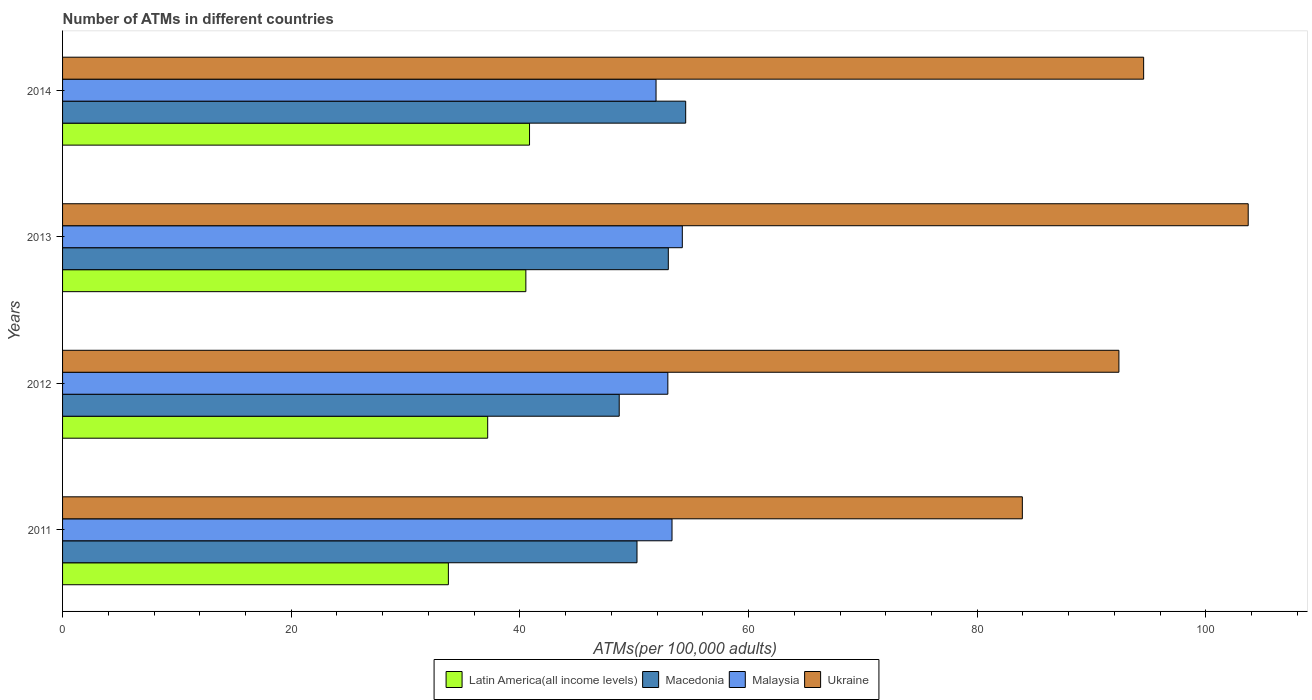How many different coloured bars are there?
Offer a very short reply. 4. How many bars are there on the 4th tick from the top?
Provide a succinct answer. 4. What is the label of the 2nd group of bars from the top?
Ensure brevity in your answer.  2013. What is the number of ATMs in Ukraine in 2011?
Provide a succinct answer. 83.95. Across all years, what is the maximum number of ATMs in Latin America(all income levels)?
Keep it short and to the point. 40.84. Across all years, what is the minimum number of ATMs in Malaysia?
Ensure brevity in your answer.  51.91. What is the total number of ATMs in Malaysia in the graph?
Give a very brief answer. 212.36. What is the difference between the number of ATMs in Macedonia in 2011 and that in 2012?
Offer a very short reply. 1.56. What is the difference between the number of ATMs in Macedonia in 2011 and the number of ATMs in Malaysia in 2012?
Provide a short and direct response. -2.7. What is the average number of ATMs in Macedonia per year?
Your answer should be compact. 51.6. In the year 2013, what is the difference between the number of ATMs in Ukraine and number of ATMs in Macedonia?
Give a very brief answer. 50.72. In how many years, is the number of ATMs in Ukraine greater than 80 ?
Keep it short and to the point. 4. What is the ratio of the number of ATMs in Latin America(all income levels) in 2011 to that in 2012?
Your answer should be compact. 0.91. Is the number of ATMs in Malaysia in 2011 less than that in 2013?
Your answer should be very brief. Yes. Is the difference between the number of ATMs in Ukraine in 2011 and 2012 greater than the difference between the number of ATMs in Macedonia in 2011 and 2012?
Your answer should be compact. No. What is the difference between the highest and the second highest number of ATMs in Ukraine?
Give a very brief answer. 9.15. What is the difference between the highest and the lowest number of ATMs in Macedonia?
Keep it short and to the point. 5.81. Is it the case that in every year, the sum of the number of ATMs in Latin America(all income levels) and number of ATMs in Macedonia is greater than the sum of number of ATMs in Ukraine and number of ATMs in Malaysia?
Your response must be concise. No. What does the 3rd bar from the top in 2012 represents?
Keep it short and to the point. Macedonia. What does the 2nd bar from the bottom in 2013 represents?
Your answer should be compact. Macedonia. Is it the case that in every year, the sum of the number of ATMs in Ukraine and number of ATMs in Macedonia is greater than the number of ATMs in Latin America(all income levels)?
Make the answer very short. Yes. How many bars are there?
Keep it short and to the point. 16. How many years are there in the graph?
Offer a terse response. 4. What is the difference between two consecutive major ticks on the X-axis?
Provide a succinct answer. 20. Does the graph contain any zero values?
Offer a terse response. No. Does the graph contain grids?
Ensure brevity in your answer.  No. How many legend labels are there?
Ensure brevity in your answer.  4. How are the legend labels stacked?
Your answer should be very brief. Horizontal. What is the title of the graph?
Offer a terse response. Number of ATMs in different countries. Does "Sub-Saharan Africa (developing only)" appear as one of the legend labels in the graph?
Provide a short and direct response. No. What is the label or title of the X-axis?
Offer a very short reply. ATMs(per 100,0 adults). What is the ATMs(per 100,000 adults) of Latin America(all income levels) in 2011?
Provide a succinct answer. 33.74. What is the ATMs(per 100,000 adults) of Macedonia in 2011?
Keep it short and to the point. 50.24. What is the ATMs(per 100,000 adults) in Malaysia in 2011?
Your answer should be compact. 53.31. What is the ATMs(per 100,000 adults) in Ukraine in 2011?
Offer a terse response. 83.95. What is the ATMs(per 100,000 adults) of Latin America(all income levels) in 2012?
Offer a terse response. 37.18. What is the ATMs(per 100,000 adults) of Macedonia in 2012?
Your answer should be very brief. 48.69. What is the ATMs(per 100,000 adults) of Malaysia in 2012?
Your answer should be compact. 52.94. What is the ATMs(per 100,000 adults) of Ukraine in 2012?
Your answer should be compact. 92.39. What is the ATMs(per 100,000 adults) in Latin America(all income levels) in 2013?
Your answer should be compact. 40.52. What is the ATMs(per 100,000 adults) in Macedonia in 2013?
Keep it short and to the point. 52.98. What is the ATMs(per 100,000 adults) of Malaysia in 2013?
Keep it short and to the point. 54.21. What is the ATMs(per 100,000 adults) of Ukraine in 2013?
Your response must be concise. 103.7. What is the ATMs(per 100,000 adults) in Latin America(all income levels) in 2014?
Ensure brevity in your answer.  40.84. What is the ATMs(per 100,000 adults) of Macedonia in 2014?
Offer a very short reply. 54.5. What is the ATMs(per 100,000 adults) in Malaysia in 2014?
Give a very brief answer. 51.91. What is the ATMs(per 100,000 adults) of Ukraine in 2014?
Your answer should be compact. 94.56. Across all years, what is the maximum ATMs(per 100,000 adults) in Latin America(all income levels)?
Ensure brevity in your answer.  40.84. Across all years, what is the maximum ATMs(per 100,000 adults) of Macedonia?
Your answer should be very brief. 54.5. Across all years, what is the maximum ATMs(per 100,000 adults) in Malaysia?
Your response must be concise. 54.21. Across all years, what is the maximum ATMs(per 100,000 adults) of Ukraine?
Provide a short and direct response. 103.7. Across all years, what is the minimum ATMs(per 100,000 adults) in Latin America(all income levels)?
Keep it short and to the point. 33.74. Across all years, what is the minimum ATMs(per 100,000 adults) of Macedonia?
Provide a succinct answer. 48.69. Across all years, what is the minimum ATMs(per 100,000 adults) of Malaysia?
Your answer should be very brief. 51.91. Across all years, what is the minimum ATMs(per 100,000 adults) in Ukraine?
Give a very brief answer. 83.95. What is the total ATMs(per 100,000 adults) in Latin America(all income levels) in the graph?
Keep it short and to the point. 152.29. What is the total ATMs(per 100,000 adults) of Macedonia in the graph?
Give a very brief answer. 206.41. What is the total ATMs(per 100,000 adults) in Malaysia in the graph?
Your response must be concise. 212.36. What is the total ATMs(per 100,000 adults) in Ukraine in the graph?
Offer a terse response. 374.6. What is the difference between the ATMs(per 100,000 adults) of Latin America(all income levels) in 2011 and that in 2012?
Give a very brief answer. -3.44. What is the difference between the ATMs(per 100,000 adults) of Macedonia in 2011 and that in 2012?
Your answer should be compact. 1.56. What is the difference between the ATMs(per 100,000 adults) in Malaysia in 2011 and that in 2012?
Your answer should be very brief. 0.36. What is the difference between the ATMs(per 100,000 adults) in Ukraine in 2011 and that in 2012?
Provide a succinct answer. -8.45. What is the difference between the ATMs(per 100,000 adults) of Latin America(all income levels) in 2011 and that in 2013?
Your response must be concise. -6.78. What is the difference between the ATMs(per 100,000 adults) in Macedonia in 2011 and that in 2013?
Provide a succinct answer. -2.74. What is the difference between the ATMs(per 100,000 adults) in Malaysia in 2011 and that in 2013?
Offer a very short reply. -0.9. What is the difference between the ATMs(per 100,000 adults) of Ukraine in 2011 and that in 2013?
Your response must be concise. -19.76. What is the difference between the ATMs(per 100,000 adults) in Latin America(all income levels) in 2011 and that in 2014?
Your response must be concise. -7.1. What is the difference between the ATMs(per 100,000 adults) in Macedonia in 2011 and that in 2014?
Your answer should be very brief. -4.26. What is the difference between the ATMs(per 100,000 adults) of Malaysia in 2011 and that in 2014?
Your answer should be very brief. 1.4. What is the difference between the ATMs(per 100,000 adults) in Ukraine in 2011 and that in 2014?
Ensure brevity in your answer.  -10.61. What is the difference between the ATMs(per 100,000 adults) in Latin America(all income levels) in 2012 and that in 2013?
Your answer should be compact. -3.34. What is the difference between the ATMs(per 100,000 adults) of Macedonia in 2012 and that in 2013?
Offer a terse response. -4.29. What is the difference between the ATMs(per 100,000 adults) of Malaysia in 2012 and that in 2013?
Make the answer very short. -1.27. What is the difference between the ATMs(per 100,000 adults) of Ukraine in 2012 and that in 2013?
Offer a terse response. -11.31. What is the difference between the ATMs(per 100,000 adults) in Latin America(all income levels) in 2012 and that in 2014?
Your answer should be compact. -3.66. What is the difference between the ATMs(per 100,000 adults) in Macedonia in 2012 and that in 2014?
Keep it short and to the point. -5.81. What is the difference between the ATMs(per 100,000 adults) of Malaysia in 2012 and that in 2014?
Keep it short and to the point. 1.03. What is the difference between the ATMs(per 100,000 adults) of Ukraine in 2012 and that in 2014?
Give a very brief answer. -2.16. What is the difference between the ATMs(per 100,000 adults) of Latin America(all income levels) in 2013 and that in 2014?
Ensure brevity in your answer.  -0.32. What is the difference between the ATMs(per 100,000 adults) in Macedonia in 2013 and that in 2014?
Your answer should be compact. -1.52. What is the difference between the ATMs(per 100,000 adults) of Malaysia in 2013 and that in 2014?
Offer a terse response. 2.3. What is the difference between the ATMs(per 100,000 adults) of Ukraine in 2013 and that in 2014?
Your response must be concise. 9.15. What is the difference between the ATMs(per 100,000 adults) in Latin America(all income levels) in 2011 and the ATMs(per 100,000 adults) in Macedonia in 2012?
Your answer should be very brief. -14.94. What is the difference between the ATMs(per 100,000 adults) in Latin America(all income levels) in 2011 and the ATMs(per 100,000 adults) in Malaysia in 2012?
Give a very brief answer. -19.2. What is the difference between the ATMs(per 100,000 adults) of Latin America(all income levels) in 2011 and the ATMs(per 100,000 adults) of Ukraine in 2012?
Keep it short and to the point. -58.65. What is the difference between the ATMs(per 100,000 adults) in Macedonia in 2011 and the ATMs(per 100,000 adults) in Malaysia in 2012?
Offer a very short reply. -2.7. What is the difference between the ATMs(per 100,000 adults) in Macedonia in 2011 and the ATMs(per 100,000 adults) in Ukraine in 2012?
Provide a succinct answer. -42.15. What is the difference between the ATMs(per 100,000 adults) in Malaysia in 2011 and the ATMs(per 100,000 adults) in Ukraine in 2012?
Your answer should be very brief. -39.09. What is the difference between the ATMs(per 100,000 adults) in Latin America(all income levels) in 2011 and the ATMs(per 100,000 adults) in Macedonia in 2013?
Your response must be concise. -19.24. What is the difference between the ATMs(per 100,000 adults) of Latin America(all income levels) in 2011 and the ATMs(per 100,000 adults) of Malaysia in 2013?
Ensure brevity in your answer.  -20.46. What is the difference between the ATMs(per 100,000 adults) of Latin America(all income levels) in 2011 and the ATMs(per 100,000 adults) of Ukraine in 2013?
Ensure brevity in your answer.  -69.96. What is the difference between the ATMs(per 100,000 adults) of Macedonia in 2011 and the ATMs(per 100,000 adults) of Malaysia in 2013?
Give a very brief answer. -3.96. What is the difference between the ATMs(per 100,000 adults) of Macedonia in 2011 and the ATMs(per 100,000 adults) of Ukraine in 2013?
Keep it short and to the point. -53.46. What is the difference between the ATMs(per 100,000 adults) in Malaysia in 2011 and the ATMs(per 100,000 adults) in Ukraine in 2013?
Provide a succinct answer. -50.4. What is the difference between the ATMs(per 100,000 adults) of Latin America(all income levels) in 2011 and the ATMs(per 100,000 adults) of Macedonia in 2014?
Offer a very short reply. -20.76. What is the difference between the ATMs(per 100,000 adults) of Latin America(all income levels) in 2011 and the ATMs(per 100,000 adults) of Malaysia in 2014?
Provide a short and direct response. -18.16. What is the difference between the ATMs(per 100,000 adults) of Latin America(all income levels) in 2011 and the ATMs(per 100,000 adults) of Ukraine in 2014?
Offer a terse response. -60.81. What is the difference between the ATMs(per 100,000 adults) of Macedonia in 2011 and the ATMs(per 100,000 adults) of Malaysia in 2014?
Offer a terse response. -1.66. What is the difference between the ATMs(per 100,000 adults) of Macedonia in 2011 and the ATMs(per 100,000 adults) of Ukraine in 2014?
Keep it short and to the point. -44.31. What is the difference between the ATMs(per 100,000 adults) of Malaysia in 2011 and the ATMs(per 100,000 adults) of Ukraine in 2014?
Make the answer very short. -41.25. What is the difference between the ATMs(per 100,000 adults) in Latin America(all income levels) in 2012 and the ATMs(per 100,000 adults) in Macedonia in 2013?
Provide a succinct answer. -15.8. What is the difference between the ATMs(per 100,000 adults) in Latin America(all income levels) in 2012 and the ATMs(per 100,000 adults) in Malaysia in 2013?
Keep it short and to the point. -17.02. What is the difference between the ATMs(per 100,000 adults) in Latin America(all income levels) in 2012 and the ATMs(per 100,000 adults) in Ukraine in 2013?
Your response must be concise. -66.52. What is the difference between the ATMs(per 100,000 adults) in Macedonia in 2012 and the ATMs(per 100,000 adults) in Malaysia in 2013?
Offer a terse response. -5.52. What is the difference between the ATMs(per 100,000 adults) in Macedonia in 2012 and the ATMs(per 100,000 adults) in Ukraine in 2013?
Your answer should be very brief. -55.02. What is the difference between the ATMs(per 100,000 adults) of Malaysia in 2012 and the ATMs(per 100,000 adults) of Ukraine in 2013?
Keep it short and to the point. -50.76. What is the difference between the ATMs(per 100,000 adults) in Latin America(all income levels) in 2012 and the ATMs(per 100,000 adults) in Macedonia in 2014?
Give a very brief answer. -17.32. What is the difference between the ATMs(per 100,000 adults) of Latin America(all income levels) in 2012 and the ATMs(per 100,000 adults) of Malaysia in 2014?
Provide a short and direct response. -14.72. What is the difference between the ATMs(per 100,000 adults) of Latin America(all income levels) in 2012 and the ATMs(per 100,000 adults) of Ukraine in 2014?
Give a very brief answer. -57.37. What is the difference between the ATMs(per 100,000 adults) in Macedonia in 2012 and the ATMs(per 100,000 adults) in Malaysia in 2014?
Keep it short and to the point. -3.22. What is the difference between the ATMs(per 100,000 adults) of Macedonia in 2012 and the ATMs(per 100,000 adults) of Ukraine in 2014?
Offer a terse response. -45.87. What is the difference between the ATMs(per 100,000 adults) in Malaysia in 2012 and the ATMs(per 100,000 adults) in Ukraine in 2014?
Give a very brief answer. -41.62. What is the difference between the ATMs(per 100,000 adults) of Latin America(all income levels) in 2013 and the ATMs(per 100,000 adults) of Macedonia in 2014?
Keep it short and to the point. -13.98. What is the difference between the ATMs(per 100,000 adults) of Latin America(all income levels) in 2013 and the ATMs(per 100,000 adults) of Malaysia in 2014?
Offer a terse response. -11.39. What is the difference between the ATMs(per 100,000 adults) in Latin America(all income levels) in 2013 and the ATMs(per 100,000 adults) in Ukraine in 2014?
Offer a terse response. -54.03. What is the difference between the ATMs(per 100,000 adults) in Macedonia in 2013 and the ATMs(per 100,000 adults) in Malaysia in 2014?
Keep it short and to the point. 1.07. What is the difference between the ATMs(per 100,000 adults) of Macedonia in 2013 and the ATMs(per 100,000 adults) of Ukraine in 2014?
Ensure brevity in your answer.  -41.57. What is the difference between the ATMs(per 100,000 adults) of Malaysia in 2013 and the ATMs(per 100,000 adults) of Ukraine in 2014?
Keep it short and to the point. -40.35. What is the average ATMs(per 100,000 adults) in Latin America(all income levels) per year?
Provide a succinct answer. 38.07. What is the average ATMs(per 100,000 adults) of Macedonia per year?
Your response must be concise. 51.6. What is the average ATMs(per 100,000 adults) of Malaysia per year?
Give a very brief answer. 53.09. What is the average ATMs(per 100,000 adults) of Ukraine per year?
Your answer should be very brief. 93.65. In the year 2011, what is the difference between the ATMs(per 100,000 adults) in Latin America(all income levels) and ATMs(per 100,000 adults) in Macedonia?
Make the answer very short. -16.5. In the year 2011, what is the difference between the ATMs(per 100,000 adults) of Latin America(all income levels) and ATMs(per 100,000 adults) of Malaysia?
Keep it short and to the point. -19.56. In the year 2011, what is the difference between the ATMs(per 100,000 adults) in Latin America(all income levels) and ATMs(per 100,000 adults) in Ukraine?
Your answer should be very brief. -50.2. In the year 2011, what is the difference between the ATMs(per 100,000 adults) of Macedonia and ATMs(per 100,000 adults) of Malaysia?
Provide a short and direct response. -3.06. In the year 2011, what is the difference between the ATMs(per 100,000 adults) in Macedonia and ATMs(per 100,000 adults) in Ukraine?
Offer a terse response. -33.7. In the year 2011, what is the difference between the ATMs(per 100,000 adults) of Malaysia and ATMs(per 100,000 adults) of Ukraine?
Provide a succinct answer. -30.64. In the year 2012, what is the difference between the ATMs(per 100,000 adults) of Latin America(all income levels) and ATMs(per 100,000 adults) of Macedonia?
Keep it short and to the point. -11.5. In the year 2012, what is the difference between the ATMs(per 100,000 adults) in Latin America(all income levels) and ATMs(per 100,000 adults) in Malaysia?
Provide a short and direct response. -15.76. In the year 2012, what is the difference between the ATMs(per 100,000 adults) of Latin America(all income levels) and ATMs(per 100,000 adults) of Ukraine?
Your response must be concise. -55.21. In the year 2012, what is the difference between the ATMs(per 100,000 adults) of Macedonia and ATMs(per 100,000 adults) of Malaysia?
Provide a succinct answer. -4.25. In the year 2012, what is the difference between the ATMs(per 100,000 adults) of Macedonia and ATMs(per 100,000 adults) of Ukraine?
Your answer should be very brief. -43.71. In the year 2012, what is the difference between the ATMs(per 100,000 adults) in Malaysia and ATMs(per 100,000 adults) in Ukraine?
Make the answer very short. -39.45. In the year 2013, what is the difference between the ATMs(per 100,000 adults) in Latin America(all income levels) and ATMs(per 100,000 adults) in Macedonia?
Offer a very short reply. -12.46. In the year 2013, what is the difference between the ATMs(per 100,000 adults) of Latin America(all income levels) and ATMs(per 100,000 adults) of Malaysia?
Your response must be concise. -13.68. In the year 2013, what is the difference between the ATMs(per 100,000 adults) of Latin America(all income levels) and ATMs(per 100,000 adults) of Ukraine?
Make the answer very short. -63.18. In the year 2013, what is the difference between the ATMs(per 100,000 adults) of Macedonia and ATMs(per 100,000 adults) of Malaysia?
Ensure brevity in your answer.  -1.22. In the year 2013, what is the difference between the ATMs(per 100,000 adults) in Macedonia and ATMs(per 100,000 adults) in Ukraine?
Your answer should be very brief. -50.72. In the year 2013, what is the difference between the ATMs(per 100,000 adults) in Malaysia and ATMs(per 100,000 adults) in Ukraine?
Keep it short and to the point. -49.5. In the year 2014, what is the difference between the ATMs(per 100,000 adults) of Latin America(all income levels) and ATMs(per 100,000 adults) of Macedonia?
Your response must be concise. -13.66. In the year 2014, what is the difference between the ATMs(per 100,000 adults) in Latin America(all income levels) and ATMs(per 100,000 adults) in Malaysia?
Make the answer very short. -11.06. In the year 2014, what is the difference between the ATMs(per 100,000 adults) in Latin America(all income levels) and ATMs(per 100,000 adults) in Ukraine?
Make the answer very short. -53.71. In the year 2014, what is the difference between the ATMs(per 100,000 adults) in Macedonia and ATMs(per 100,000 adults) in Malaysia?
Keep it short and to the point. 2.59. In the year 2014, what is the difference between the ATMs(per 100,000 adults) of Macedonia and ATMs(per 100,000 adults) of Ukraine?
Your response must be concise. -40.05. In the year 2014, what is the difference between the ATMs(per 100,000 adults) in Malaysia and ATMs(per 100,000 adults) in Ukraine?
Offer a terse response. -42.65. What is the ratio of the ATMs(per 100,000 adults) in Latin America(all income levels) in 2011 to that in 2012?
Your answer should be compact. 0.91. What is the ratio of the ATMs(per 100,000 adults) of Macedonia in 2011 to that in 2012?
Make the answer very short. 1.03. What is the ratio of the ATMs(per 100,000 adults) of Ukraine in 2011 to that in 2012?
Ensure brevity in your answer.  0.91. What is the ratio of the ATMs(per 100,000 adults) in Latin America(all income levels) in 2011 to that in 2013?
Provide a short and direct response. 0.83. What is the ratio of the ATMs(per 100,000 adults) of Macedonia in 2011 to that in 2013?
Your response must be concise. 0.95. What is the ratio of the ATMs(per 100,000 adults) in Malaysia in 2011 to that in 2013?
Give a very brief answer. 0.98. What is the ratio of the ATMs(per 100,000 adults) of Ukraine in 2011 to that in 2013?
Give a very brief answer. 0.81. What is the ratio of the ATMs(per 100,000 adults) in Latin America(all income levels) in 2011 to that in 2014?
Your answer should be compact. 0.83. What is the ratio of the ATMs(per 100,000 adults) in Macedonia in 2011 to that in 2014?
Offer a very short reply. 0.92. What is the ratio of the ATMs(per 100,000 adults) in Malaysia in 2011 to that in 2014?
Provide a succinct answer. 1.03. What is the ratio of the ATMs(per 100,000 adults) of Ukraine in 2011 to that in 2014?
Your response must be concise. 0.89. What is the ratio of the ATMs(per 100,000 adults) of Latin America(all income levels) in 2012 to that in 2013?
Provide a succinct answer. 0.92. What is the ratio of the ATMs(per 100,000 adults) of Macedonia in 2012 to that in 2013?
Your answer should be very brief. 0.92. What is the ratio of the ATMs(per 100,000 adults) of Malaysia in 2012 to that in 2013?
Provide a succinct answer. 0.98. What is the ratio of the ATMs(per 100,000 adults) of Ukraine in 2012 to that in 2013?
Offer a very short reply. 0.89. What is the ratio of the ATMs(per 100,000 adults) in Latin America(all income levels) in 2012 to that in 2014?
Provide a short and direct response. 0.91. What is the ratio of the ATMs(per 100,000 adults) in Macedonia in 2012 to that in 2014?
Keep it short and to the point. 0.89. What is the ratio of the ATMs(per 100,000 adults) in Malaysia in 2012 to that in 2014?
Your answer should be compact. 1.02. What is the ratio of the ATMs(per 100,000 adults) of Ukraine in 2012 to that in 2014?
Provide a succinct answer. 0.98. What is the ratio of the ATMs(per 100,000 adults) of Latin America(all income levels) in 2013 to that in 2014?
Give a very brief answer. 0.99. What is the ratio of the ATMs(per 100,000 adults) of Macedonia in 2013 to that in 2014?
Provide a short and direct response. 0.97. What is the ratio of the ATMs(per 100,000 adults) in Malaysia in 2013 to that in 2014?
Give a very brief answer. 1.04. What is the ratio of the ATMs(per 100,000 adults) of Ukraine in 2013 to that in 2014?
Your answer should be very brief. 1.1. What is the difference between the highest and the second highest ATMs(per 100,000 adults) of Latin America(all income levels)?
Give a very brief answer. 0.32. What is the difference between the highest and the second highest ATMs(per 100,000 adults) of Macedonia?
Your answer should be compact. 1.52. What is the difference between the highest and the second highest ATMs(per 100,000 adults) of Malaysia?
Keep it short and to the point. 0.9. What is the difference between the highest and the second highest ATMs(per 100,000 adults) of Ukraine?
Offer a very short reply. 9.15. What is the difference between the highest and the lowest ATMs(per 100,000 adults) of Latin America(all income levels)?
Provide a succinct answer. 7.1. What is the difference between the highest and the lowest ATMs(per 100,000 adults) in Macedonia?
Ensure brevity in your answer.  5.81. What is the difference between the highest and the lowest ATMs(per 100,000 adults) of Malaysia?
Your response must be concise. 2.3. What is the difference between the highest and the lowest ATMs(per 100,000 adults) in Ukraine?
Keep it short and to the point. 19.76. 